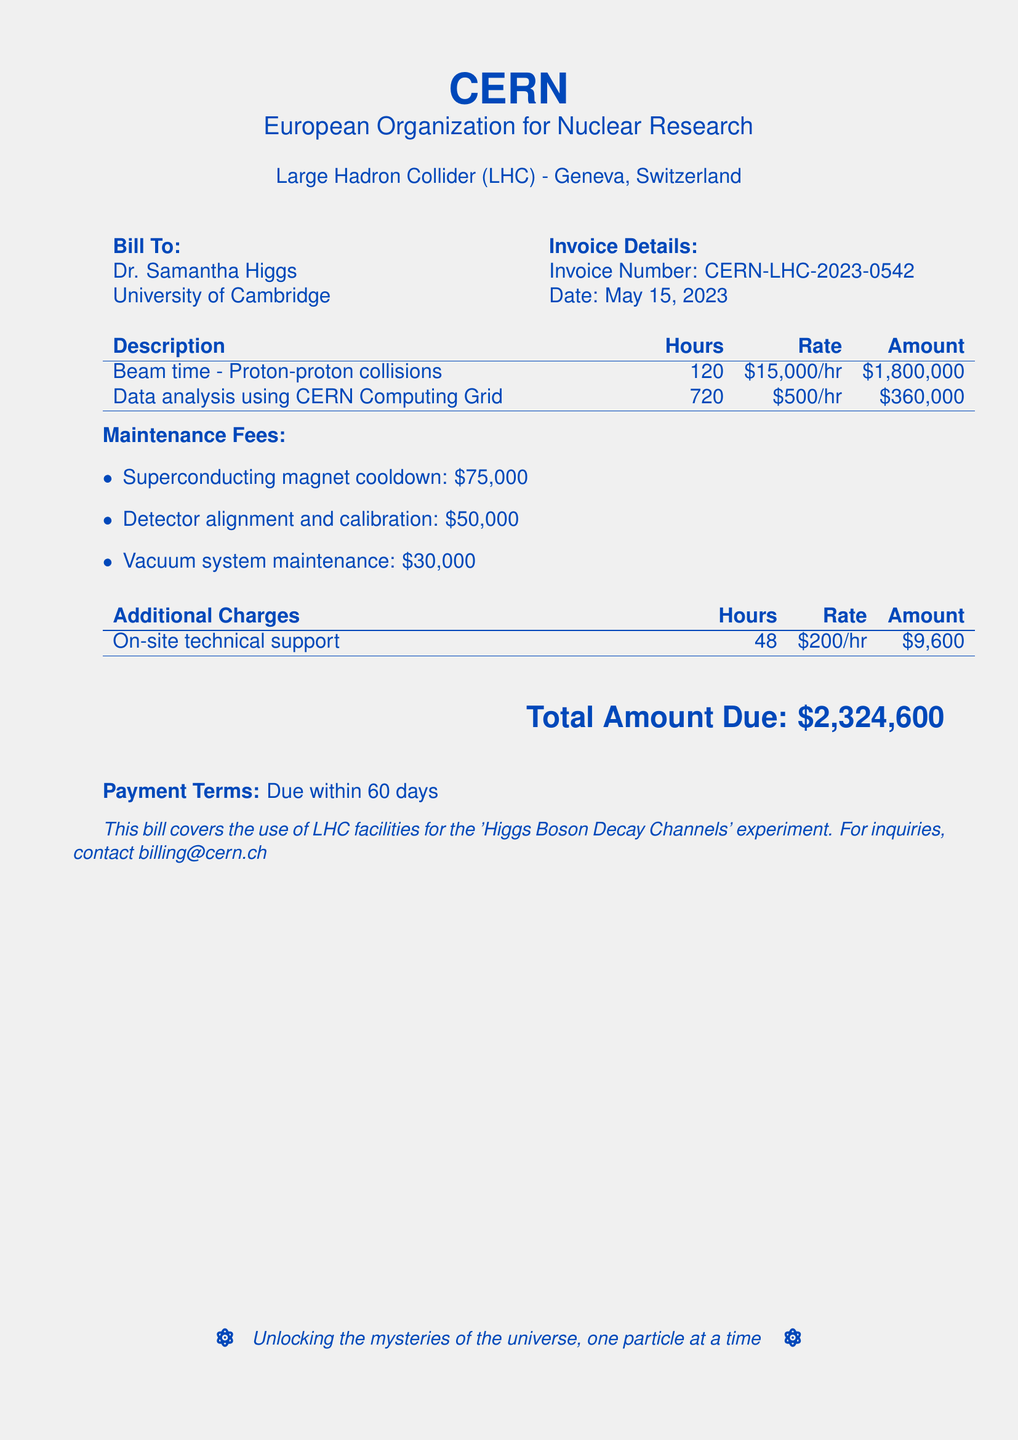what is the invoice number? The invoice number is a unique identifier found in the invoice details section of the document.
Answer: CERN-LHC-2023-0542 what is the date of the invoice? The date of the invoice is stated in the invoice details section.
Answer: May 15, 2023 how many hours of beam time were used for proton-proton collisions? This information is provided in the description of the services rendered, specifically under beam time.
Answer: 120 what is the rate for data analysis using the CERN Computing Grid? The rate is listed in the table detailing the charges for the various services.
Answer: $500/hr what is the total amount due? The total amount is the sum of all charges and fees contained in the bill.
Answer: $2,324,600 how much was charged for on-site technical support? This charge is mentioned in the additional charges section of the bill.
Answer: $9,600 what are the three maintenance fees listed? The maintenance fees are listed as individual items and can be found under the maintenance section.
Answer: Superconducting magnet cooldown, Detector alignment and calibration, Vacuum system maintenance how many hours of on-site technical support were provided? This information is included in the additional charges section of the bill.
Answer: 48 what is the payment term stated in the bill? The payment term specifies when the payment is due, located at the end of the document.
Answer: Due within 60 days 